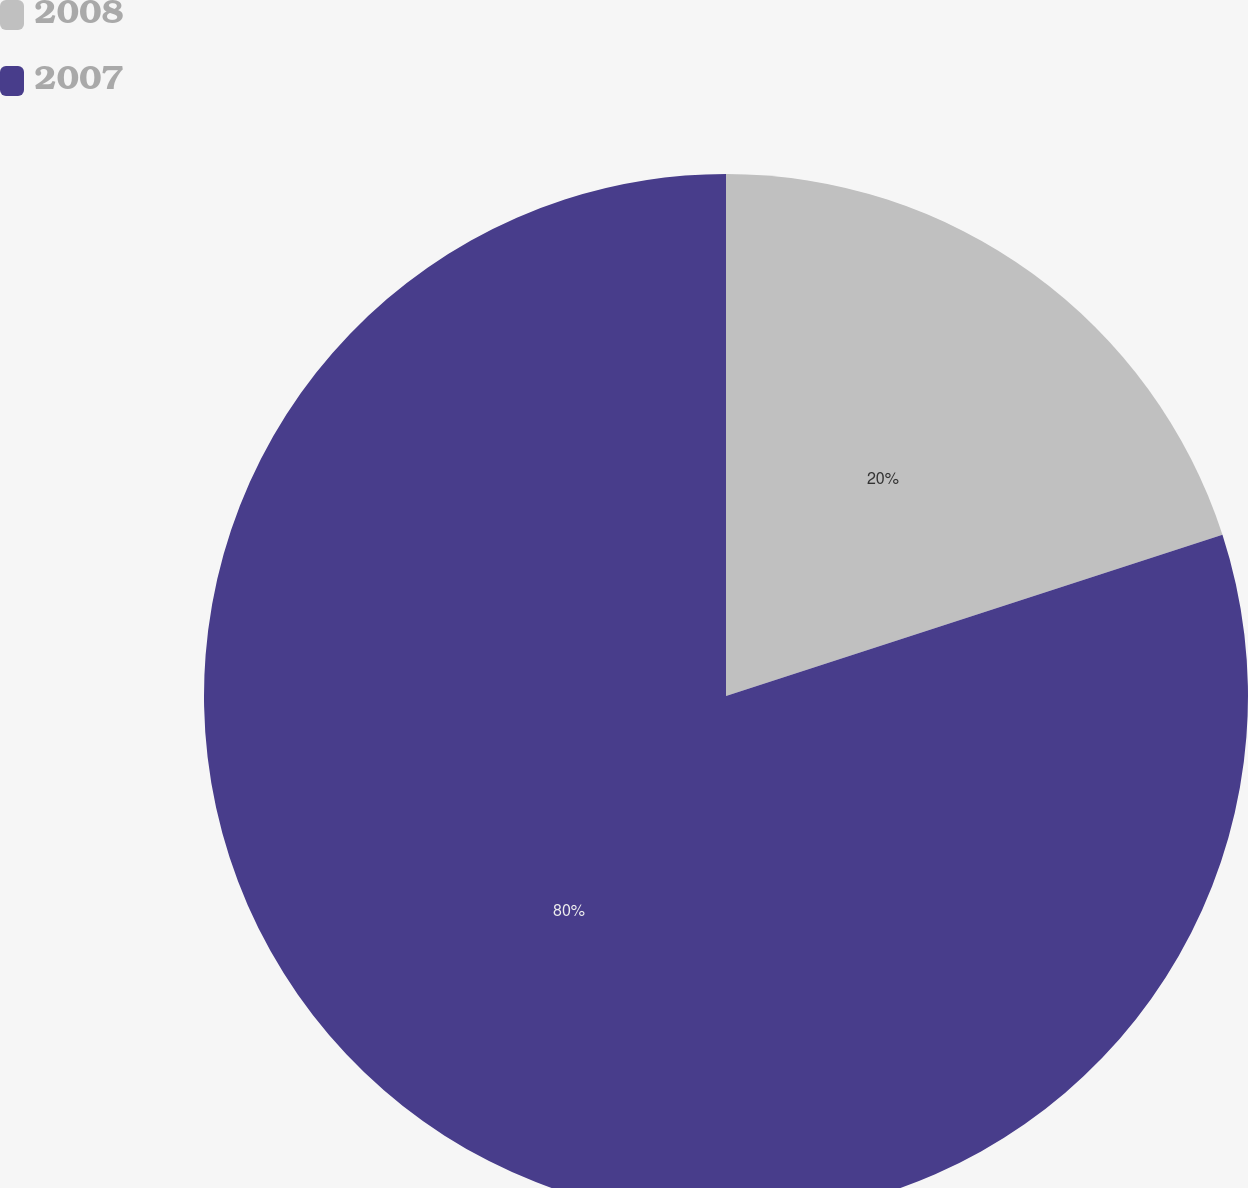<chart> <loc_0><loc_0><loc_500><loc_500><pie_chart><fcel>2008<fcel>2007<nl><fcel>20.0%<fcel>80.0%<nl></chart> 